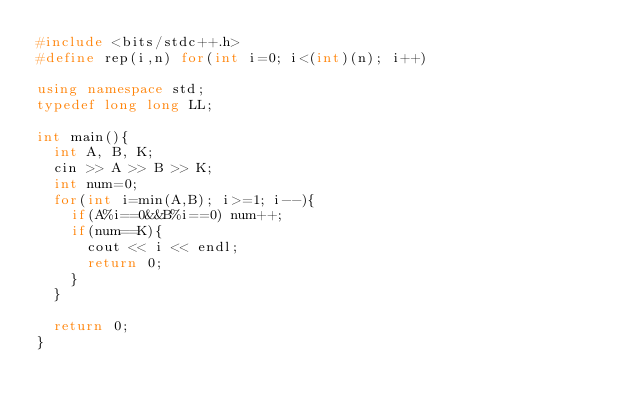<code> <loc_0><loc_0><loc_500><loc_500><_C++_>#include <bits/stdc++.h>
#define rep(i,n) for(int i=0; i<(int)(n); i++)

using namespace std;
typedef long long LL;

int main(){
  int A, B, K;
  cin >> A >> B >> K;
  int num=0;
  for(int i=min(A,B); i>=1; i--){
    if(A%i==0&&B%i==0) num++;
    if(num==K){
      cout << i << endl;
      return 0;
    }
  }

  return 0;
}
</code> 